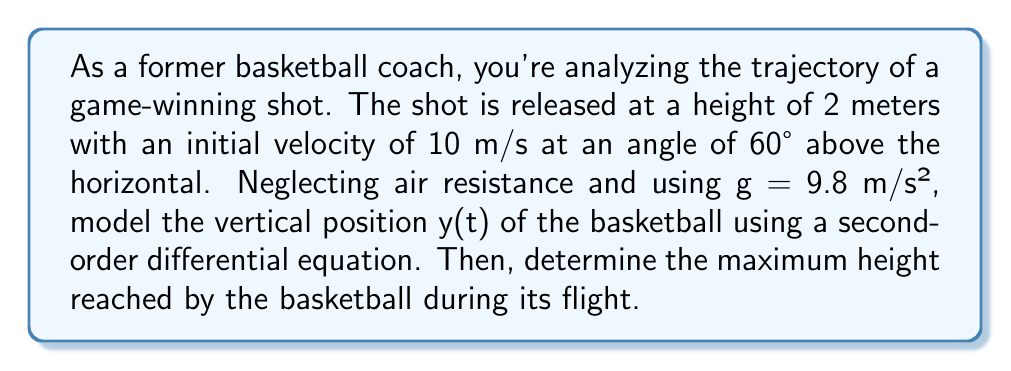What is the answer to this math problem? Let's approach this step-by-step:

1) The second-order differential equation for the vertical position y(t) of a projectile under the influence of gravity is:

   $$\frac{d^2y}{dt^2} = -g$$

   where g is the acceleration due to gravity (9.8 m/s²).

2) To solve this equation, we need two initial conditions:
   - Initial position: $y(0) = 2$ (the shot is released at 2 meters height)
   - Initial vertical velocity: $v_y(0) = 10 \sin(60°)$ (the vertical component of the initial velocity)

3) The general solution to this differential equation is:

   $$y(t) = -\frac{1}{2}gt^2 + v_0t + y_0$$

   where $v_0$ is the initial vertical velocity and $y_0$ is the initial height.

4) Calculate the initial vertical velocity:
   $$v_0 = 10 \sin(60°) = 10 \cdot \frac{\sqrt{3}}{2} = 5\sqrt{3} \approx 8.66 \text{ m/s}$$

5) Substitute the values into the general solution:

   $$y(t) = -\frac{1}{2}(9.8)t^2 + 5\sqrt{3}t + 2$$

6) To find the maximum height, we need to find when the vertical velocity is zero:

   $$\frac{dy}{dt} = -9.8t + 5\sqrt{3} = 0$$
   $$t = \frac{5\sqrt{3}}{9.8} \approx 0.88 \text{ seconds}$$

7) Substitute this time back into the position equation:

   $$y_{max} = -\frac{1}{2}(9.8)(0.88)^2 + 5\sqrt{3}(0.88) + 2$$
   $$y_{max} \approx 5.81 \text{ meters}$$

Therefore, the maximum height reached by the basketball is approximately 5.81 meters.
Answer: The vertical position of the basketball as a function of time is given by:
$$y(t) = -4.9t^2 + 5\sqrt{3}t + 2$$
The maximum height reached by the basketball is approximately 5.81 meters. 